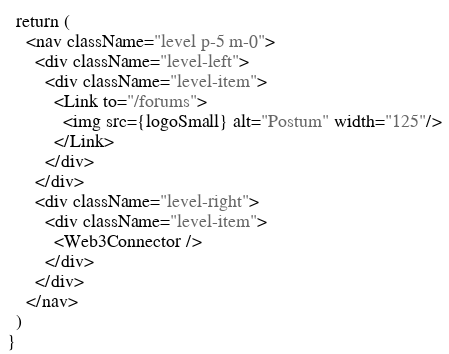<code> <loc_0><loc_0><loc_500><loc_500><_TypeScript_>  return (
    <nav className="level p-5 m-0">
      <div className="level-left">
        <div className="level-item">
          <Link to="/forums">
            <img src={logoSmall} alt="Postum" width="125"/>
          </Link>
        </div>
      </div>
      <div className="level-right">
        <div className="level-item">
          <Web3Connector />
        </div>
      </div>
    </nav>
  )
}</code> 